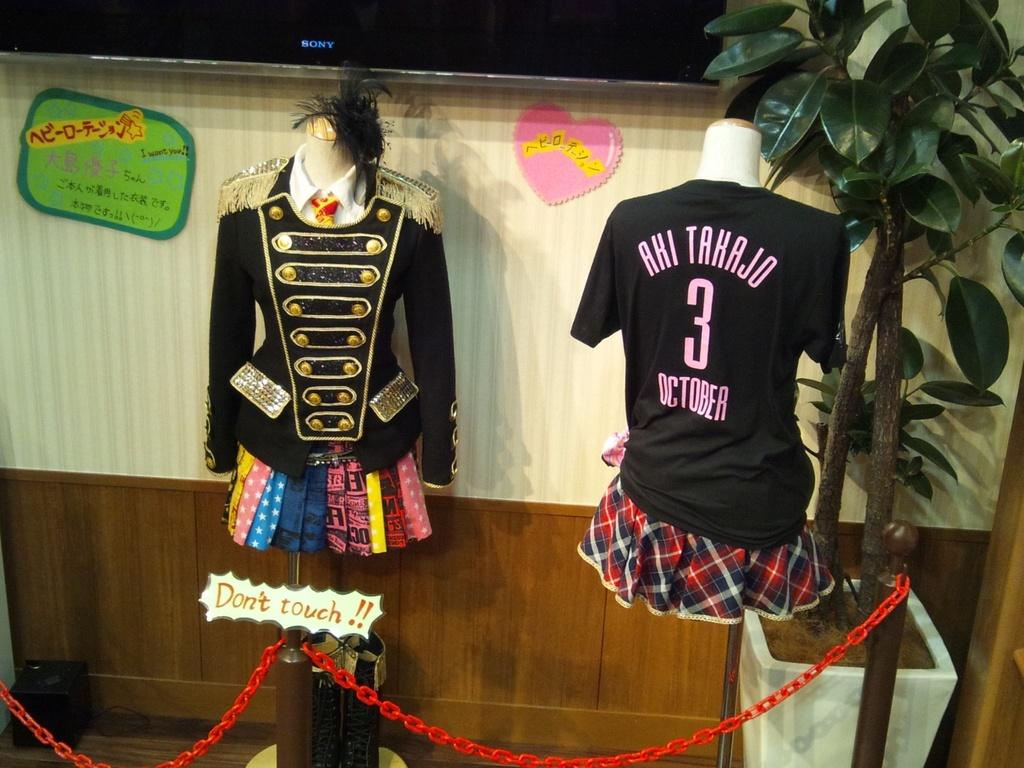<image>
Share a concise interpretation of the image provided. Two outfits turn in opposite directions with number 3 written on back. 